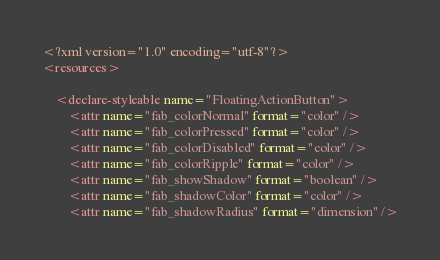Convert code to text. <code><loc_0><loc_0><loc_500><loc_500><_XML_><?xml version="1.0" encoding="utf-8"?>
<resources>

    <declare-styleable name="FloatingActionButton">
        <attr name="fab_colorNormal" format="color" />
        <attr name="fab_colorPressed" format="color" />
        <attr name="fab_colorDisabled" format="color" />
        <attr name="fab_colorRipple" format="color" />
        <attr name="fab_showShadow" format="boolean" />
        <attr name="fab_shadowColor" format="color" />
        <attr name="fab_shadowRadius" format="dimension" /></code> 